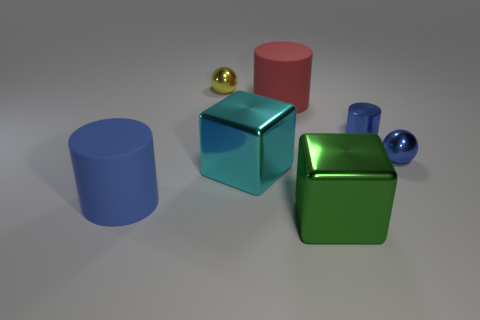Add 1 small metal things. How many objects exist? 8 Subtract all cylinders. How many objects are left? 4 Subtract 1 red cylinders. How many objects are left? 6 Subtract all blue rubber things. Subtract all blue cylinders. How many objects are left? 4 Add 6 green metal objects. How many green metal objects are left? 7 Add 7 small blue metallic cylinders. How many small blue metallic cylinders exist? 8 